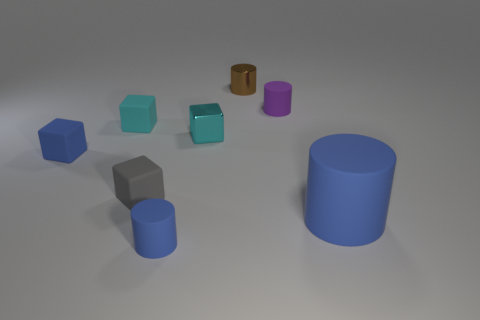Add 1 purple matte cylinders. How many objects exist? 9 Subtract 1 brown cylinders. How many objects are left? 7 Subtract all tiny blue blocks. Subtract all big blue cylinders. How many objects are left? 6 Add 5 purple rubber things. How many purple rubber things are left? 6 Add 3 rubber objects. How many rubber objects exist? 9 